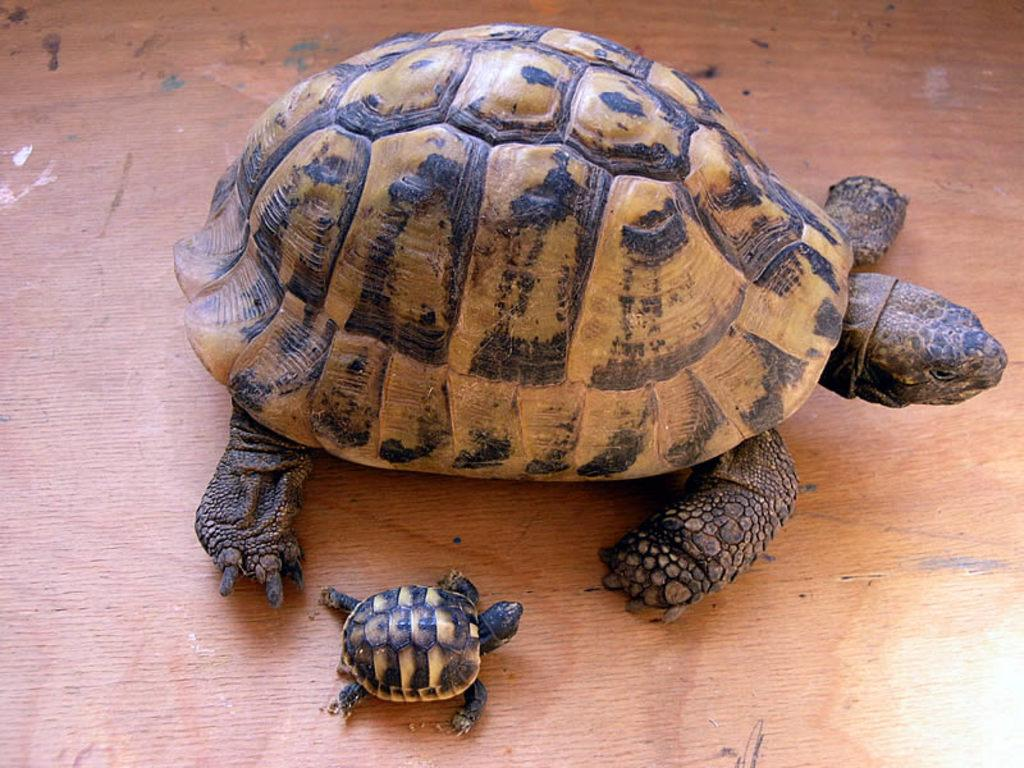How many turtles are in the image? There are two turtles in the image. What colors are the turtles? The turtles are in black and brown color. What is the surface on which the turtles are resting? The turtles are on a brown color surface. What type of shoes are the turtles wearing in the image? There are no shoes present in the image, as turtles do not wear shoes. 